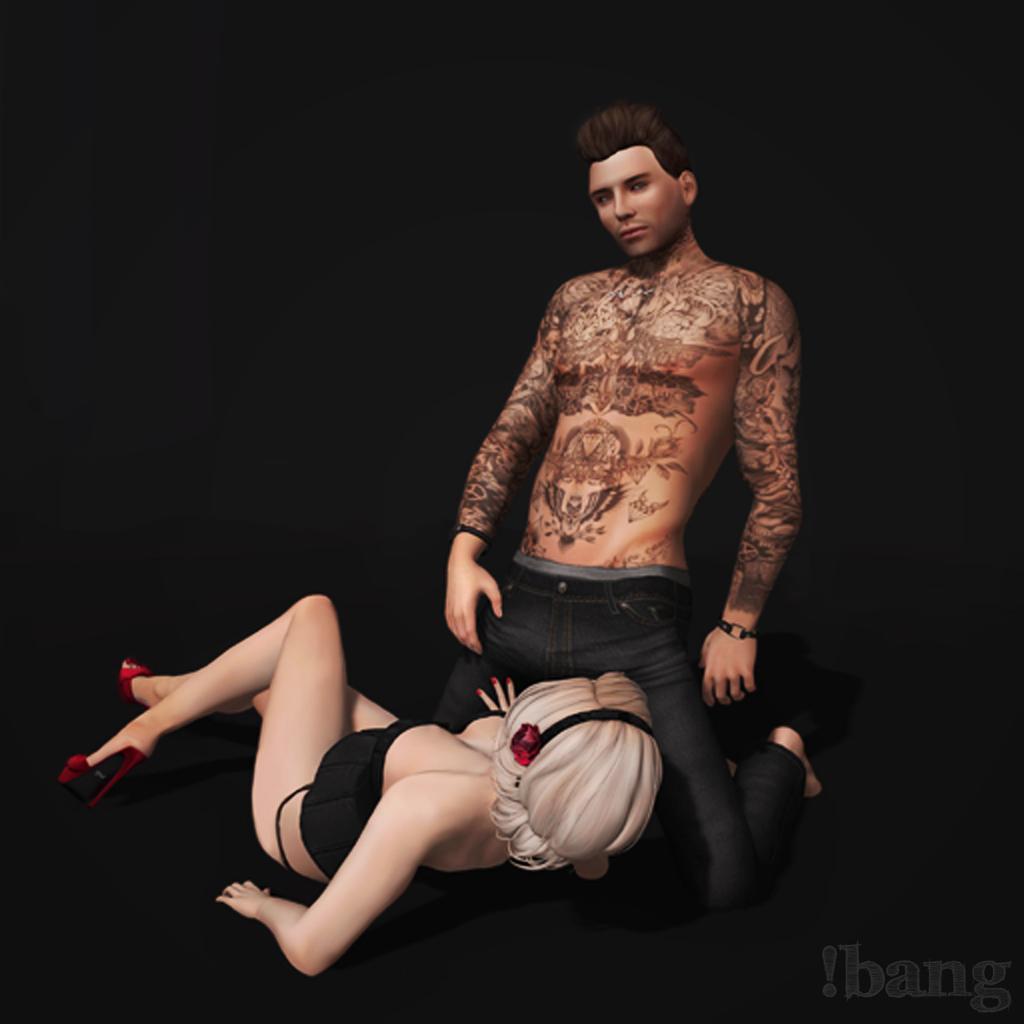Please provide a concise description of this image. In the image we can see a man and a woman, they are wearing clothes. This is a sandal and a bracelet. This is a watermark. 